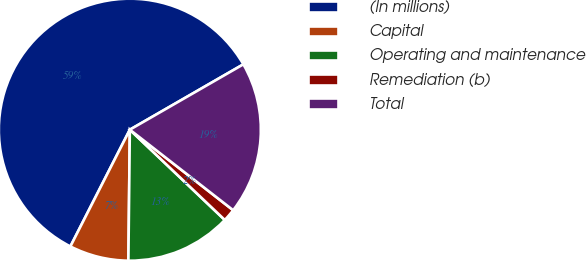Convert chart to OTSL. <chart><loc_0><loc_0><loc_500><loc_500><pie_chart><fcel>(In millions)<fcel>Capital<fcel>Operating and maintenance<fcel>Remediation (b)<fcel>Total<nl><fcel>59.19%<fcel>7.32%<fcel>13.08%<fcel>1.56%<fcel>18.85%<nl></chart> 